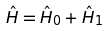<formula> <loc_0><loc_0><loc_500><loc_500>\hat { H } = \hat { H } _ { 0 } + \hat { H } _ { 1 }</formula> 